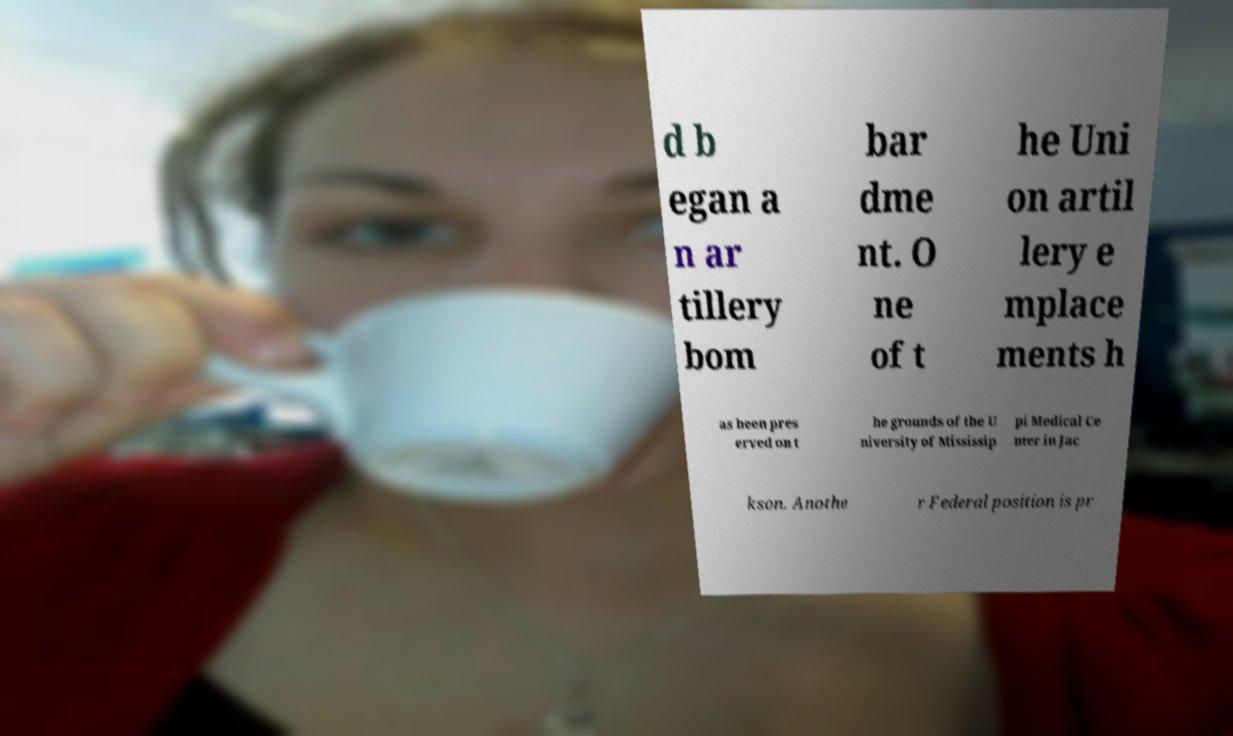I need the written content from this picture converted into text. Can you do that? d b egan a n ar tillery bom bar dme nt. O ne of t he Uni on artil lery e mplace ments h as been pres erved on t he grounds of the U niversity of Mississip pi Medical Ce nter in Jac kson. Anothe r Federal position is pr 